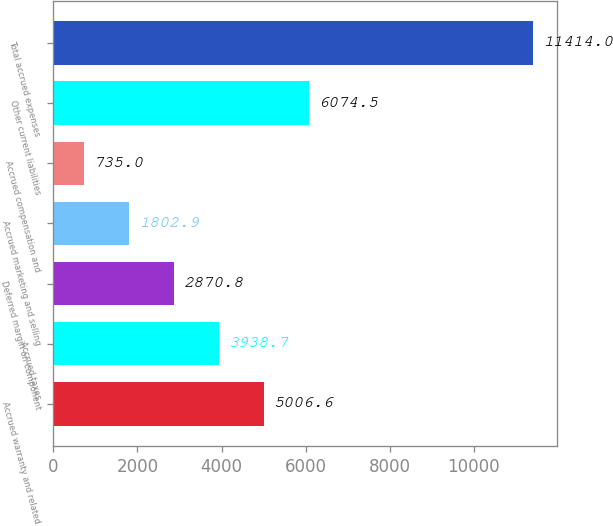Convert chart to OTSL. <chart><loc_0><loc_0><loc_500><loc_500><bar_chart><fcel>Accrued warranty and related<fcel>Accrued taxes<fcel>Deferred margin on component<fcel>Accrued marketing and selling<fcel>Accrued compensation and<fcel>Other current liabilities<fcel>Total accrued expenses<nl><fcel>5006.6<fcel>3938.7<fcel>2870.8<fcel>1802.9<fcel>735<fcel>6074.5<fcel>11414<nl></chart> 